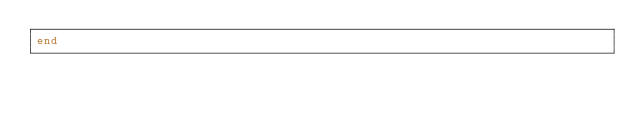<code> <loc_0><loc_0><loc_500><loc_500><_Ruby_>end
</code> 